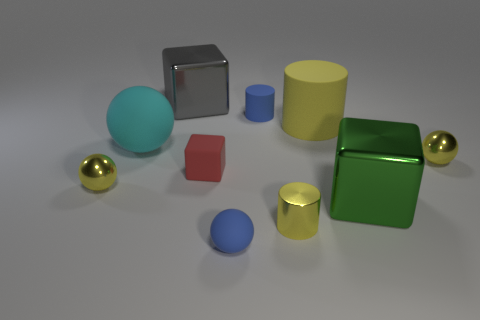Subtract all tiny rubber cubes. How many cubes are left? 2 Subtract all green blocks. How many blocks are left? 2 Subtract all spheres. How many objects are left? 6 Subtract all brown cubes. Subtract all gray balls. How many cubes are left? 3 Subtract all purple cylinders. How many gray blocks are left? 1 Subtract all large gray things. Subtract all green cubes. How many objects are left? 8 Add 1 tiny metallic things. How many tiny metallic things are left? 4 Add 1 yellow spheres. How many yellow spheres exist? 3 Subtract 0 red spheres. How many objects are left? 10 Subtract 1 blocks. How many blocks are left? 2 